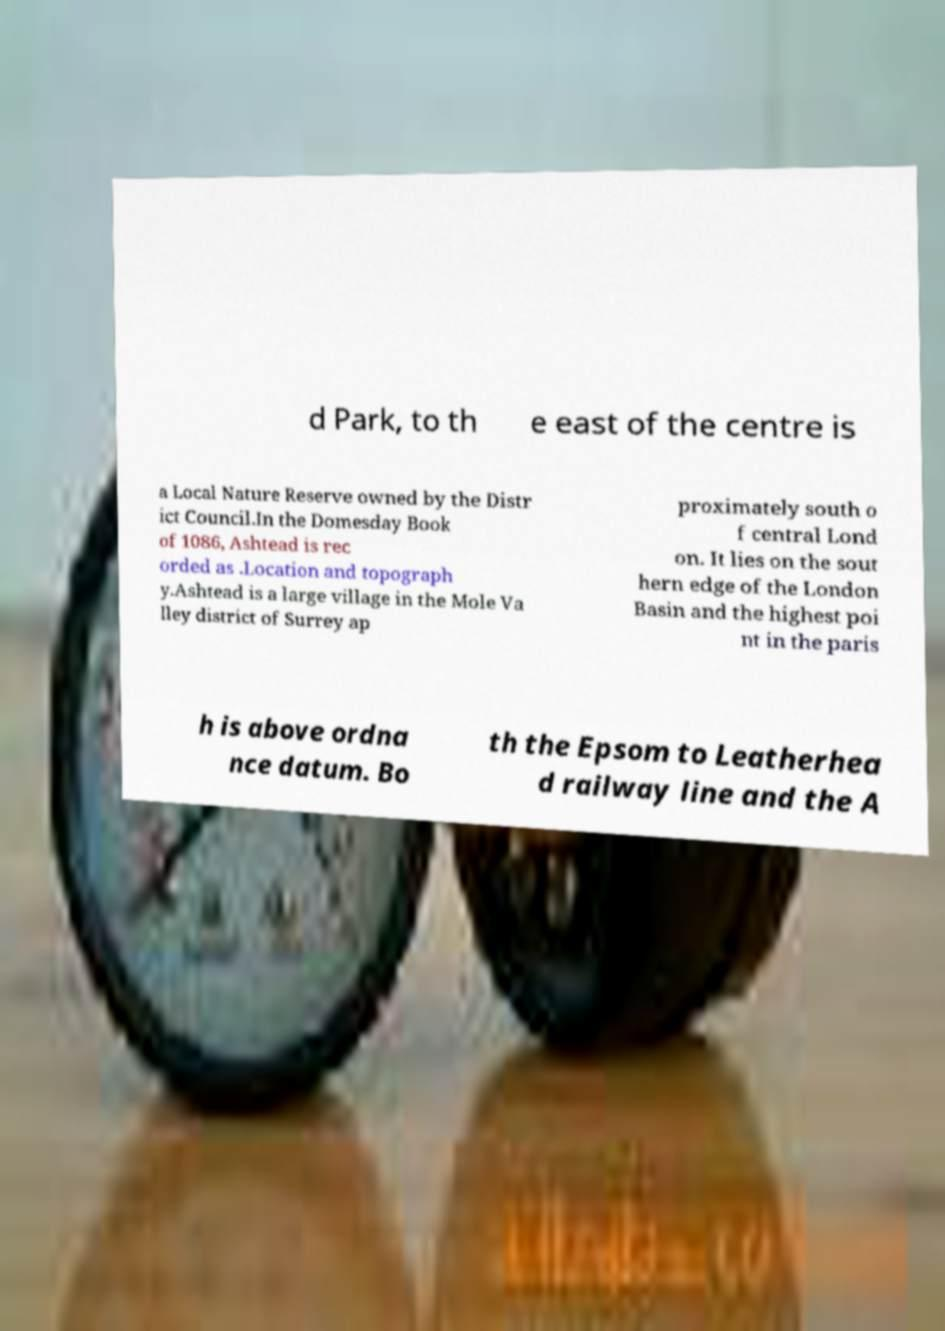I need the written content from this picture converted into text. Can you do that? d Park, to th e east of the centre is a Local Nature Reserve owned by the Distr ict Council.In the Domesday Book of 1086, Ashtead is rec orded as .Location and topograph y.Ashtead is a large village in the Mole Va lley district of Surrey ap proximately south o f central Lond on. It lies on the sout hern edge of the London Basin and the highest poi nt in the paris h is above ordna nce datum. Bo th the Epsom to Leatherhea d railway line and the A 